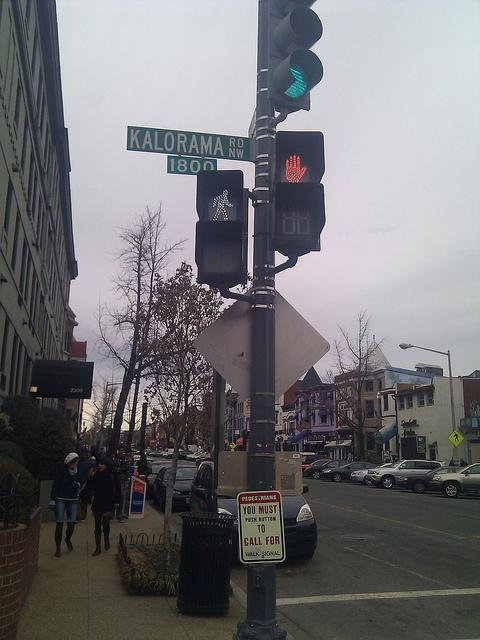The first three letters of the name of the street form the first name of what actor? Please explain your reasoning. kal penn. The street sign's first 3 letters are kal. 